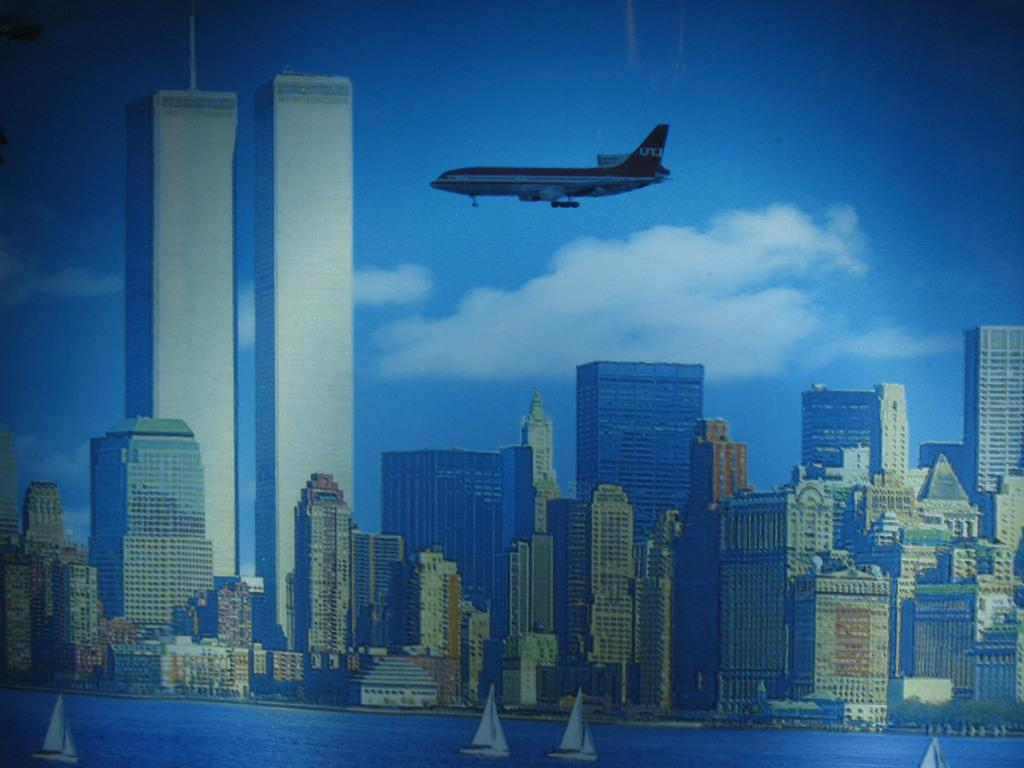What type of image is being shown? The image is an edited picture. What structures can be seen in the image? There are buildings in the image. What is located at the bottom of the image? There are boats on the water at the bottom of the image. What can be seen at the top of the image? There is an aircraft at the top of the image. What part of the natural environment is visible in the image? The sky is visible in the image. What is present in the sky? There are clouds in the sky. What type of cork is being used to hold the boats in place in the image? There is no cork present in the image; the boats are floating on the water. Does the image show any property for sale or rent? There is no indication of any property for sale or rent in the image. 